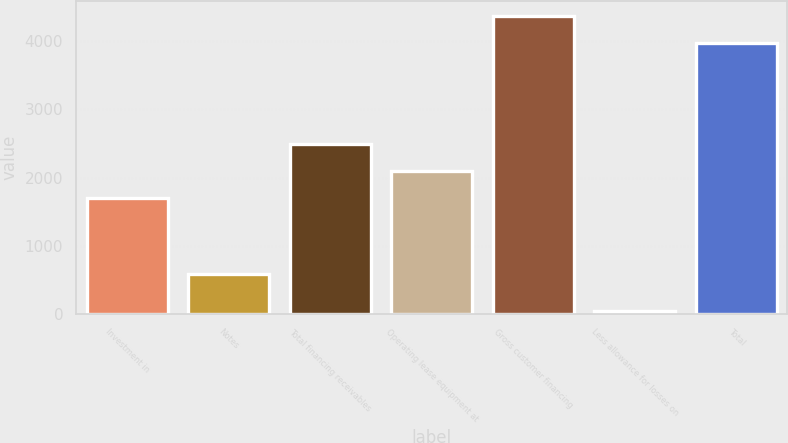<chart> <loc_0><loc_0><loc_500><loc_500><bar_chart><fcel>Investment in<fcel>Notes<fcel>Total financing receivables<fcel>Operating lease equipment at<fcel>Gross customer financing<fcel>Less allowance for losses on<fcel>Total<nl><fcel>1699<fcel>587<fcel>2493.2<fcel>2096.1<fcel>4368.1<fcel>49<fcel>3971<nl></chart> 